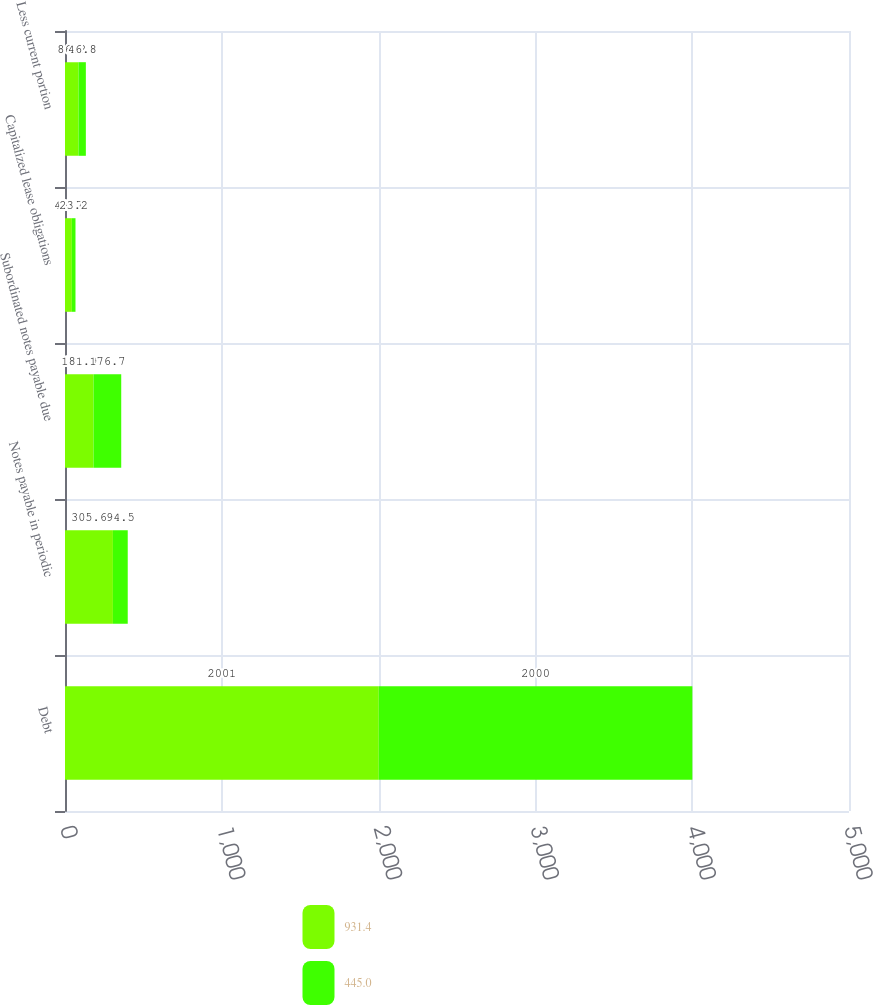<chart> <loc_0><loc_0><loc_500><loc_500><stacked_bar_chart><ecel><fcel>Debt<fcel>Notes payable in periodic<fcel>Subordinated notes payable due<fcel>Capitalized lease obligations<fcel>Less current portion<nl><fcel>931.4<fcel>2001<fcel>305.6<fcel>181.9<fcel>43.7<fcel>86.2<nl><fcel>445<fcel>2000<fcel>94.5<fcel>176.7<fcel>23.2<fcel>46.8<nl></chart> 